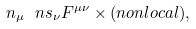Convert formula to latex. <formula><loc_0><loc_0><loc_500><loc_500>n _ { \mu } \ n s _ { \nu } F ^ { \mu \nu } \times ( n o n l o c a l ) ,</formula> 